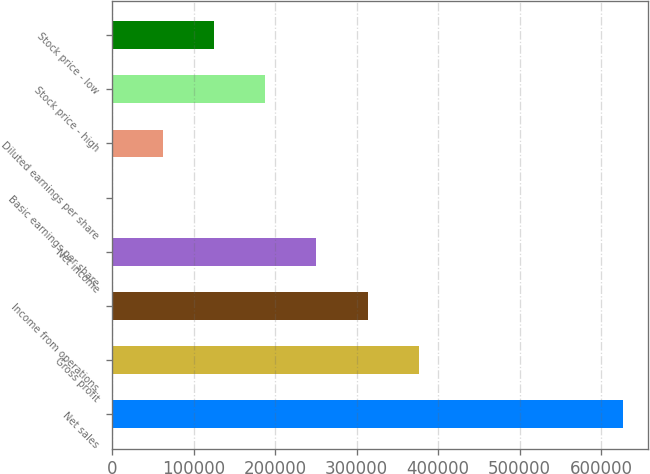<chart> <loc_0><loc_0><loc_500><loc_500><bar_chart><fcel>Net sales<fcel>Gross profit<fcel>Income from operations<fcel>Net income<fcel>Basic earnings per share<fcel>Diluted earnings per share<fcel>Stock price - high<fcel>Stock price - low<nl><fcel>626651<fcel>375991<fcel>313326<fcel>250661<fcel>0.54<fcel>62665.6<fcel>187996<fcel>125331<nl></chart> 